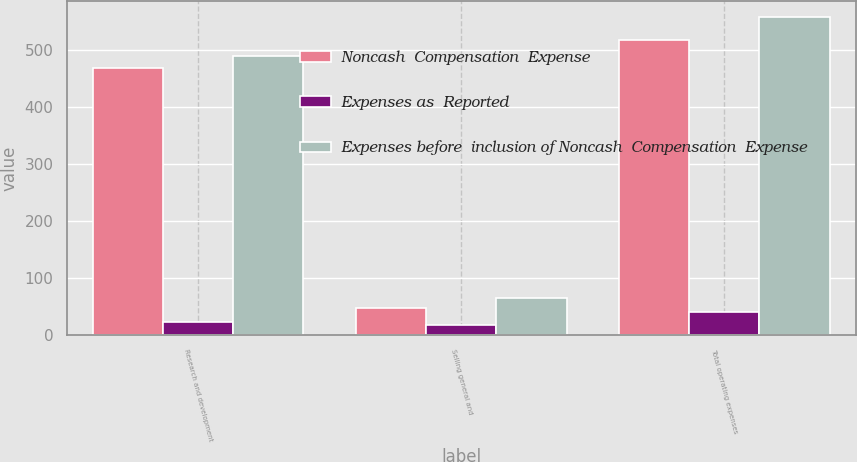Convert chart. <chart><loc_0><loc_0><loc_500><loc_500><stacked_bar_chart><ecel><fcel>Research and development<fcel>Selling general and<fcel>Total operating expenses<nl><fcel>Noncash  Compensation  Expense<fcel>466.9<fcel>47.6<fcel>516.6<nl><fcel>Expenses as  Reported<fcel>22.3<fcel>17.6<fcel>39.9<nl><fcel>Expenses before  inclusion of Noncash  Compensation  Expense<fcel>489.2<fcel>65.2<fcel>556.5<nl></chart> 